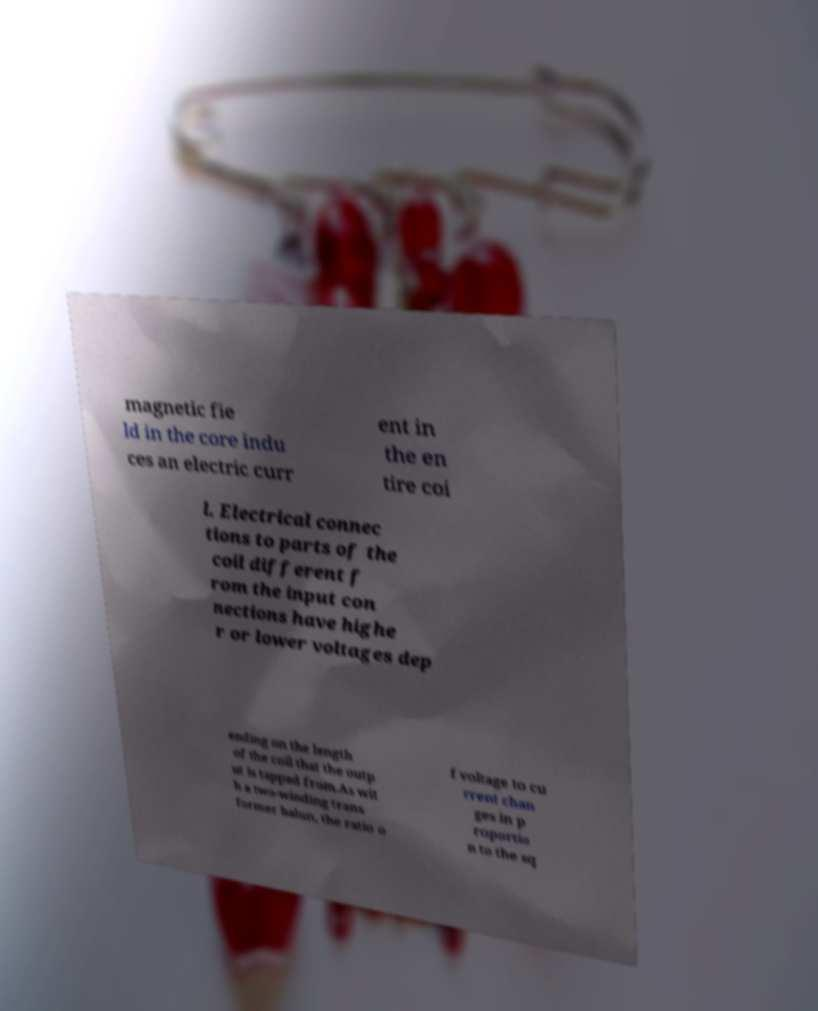Please identify and transcribe the text found in this image. magnetic fie ld in the core indu ces an electric curr ent in the en tire coi l. Electrical connec tions to parts of the coil different f rom the input con nections have highe r or lower voltages dep ending on the length of the coil that the outp ut is tapped from.As wit h a two-winding trans former balun, the ratio o f voltage to cu rrent chan ges in p roportio n to the sq 